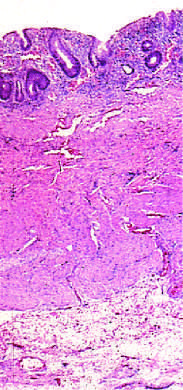does this full-thickness histologic section show that disease is limited to the mucosa?
Answer the question using a single word or phrase. Yes 